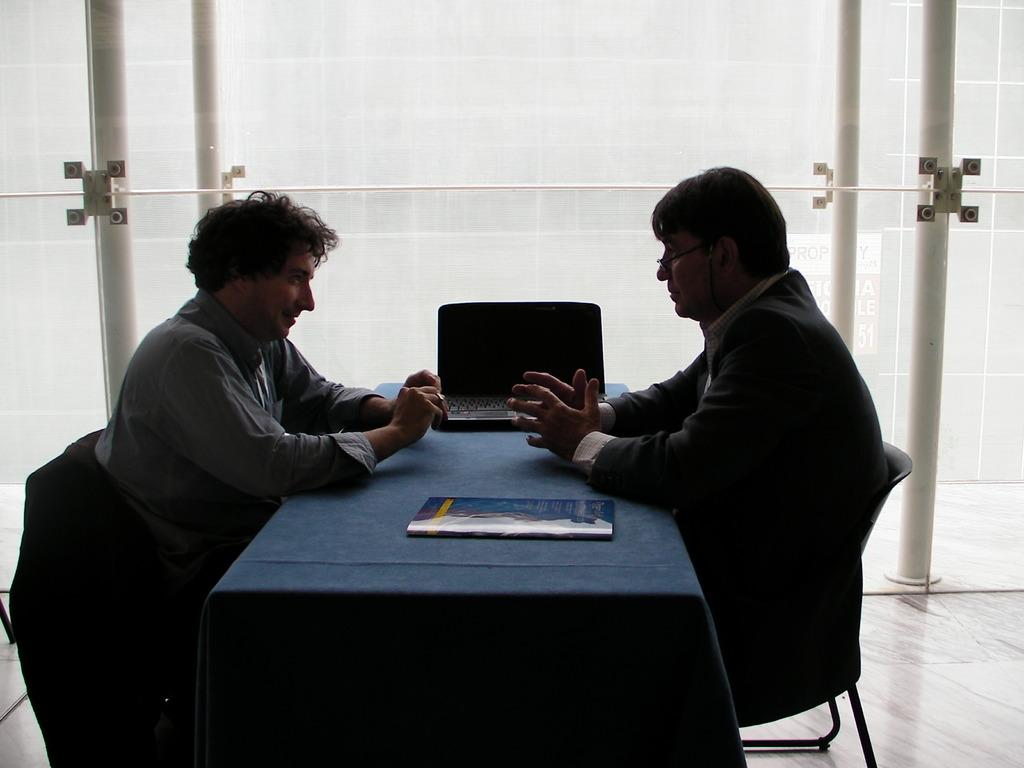How many people are in the image? There are two people in the image. What are the two people doing in the image? The two people are seated on chairs. What objects can be seen on the table in the image? There is a book and a laptop on the table. What type of comb is being used by one of the people in the image? There is no comb present in the image. How does the beef look like on the laptop screen in the image? There is no beef or laptop screen present in the image. 